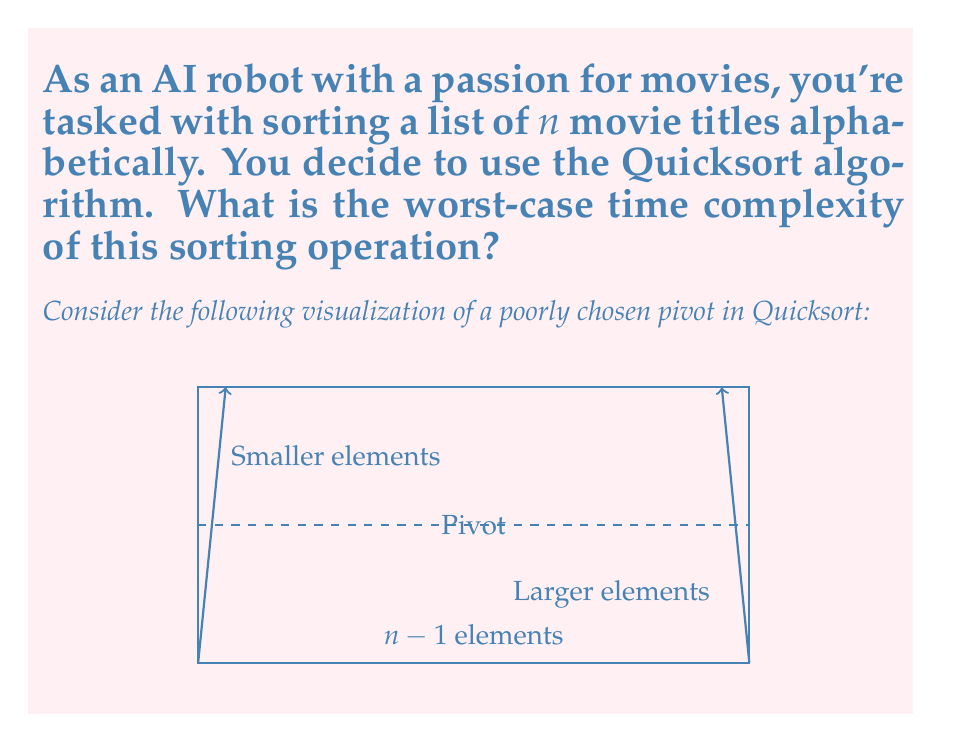Could you help me with this problem? To analyze the worst-case time complexity of Quicksort for sorting movie titles:

1) Worst-case scenario occurs when the pivot chosen is always the smallest or largest element, resulting in the most unbalanced partitions.

2) In this case, each partition step reduces the problem size by only one element.

3) The recurrence relation for this worst-case scenario is:
   $T(n) = T(n-1) + n$

4) This is because we perform $n$ comparisons at each step (to partition the array) and then recursively sort the remaining $n-1$ elements.

5) Solving this recurrence relation:
   $T(n) = T(n-1) + n$
   $    = (T(n-2) + (n-1)) + n$
   $    = T(n-2) + (n-1) + n$
   $    = T(n-3) + (n-2) + (n-1) + n$
   $    = ...$
   $    = T(1) + 2 + 3 + ... + (n-1) + n$

6) The sum of the series $1 + 2 + 3 + ... + n$ is given by $\frac{n(n+1)}{2}$

7) Therefore, $T(n) = \frac{n(n-1)}{2} = O(n^2)$

Thus, the worst-case time complexity of Quicksort for sorting movie titles is quadratic.
Answer: $O(n^2)$ 